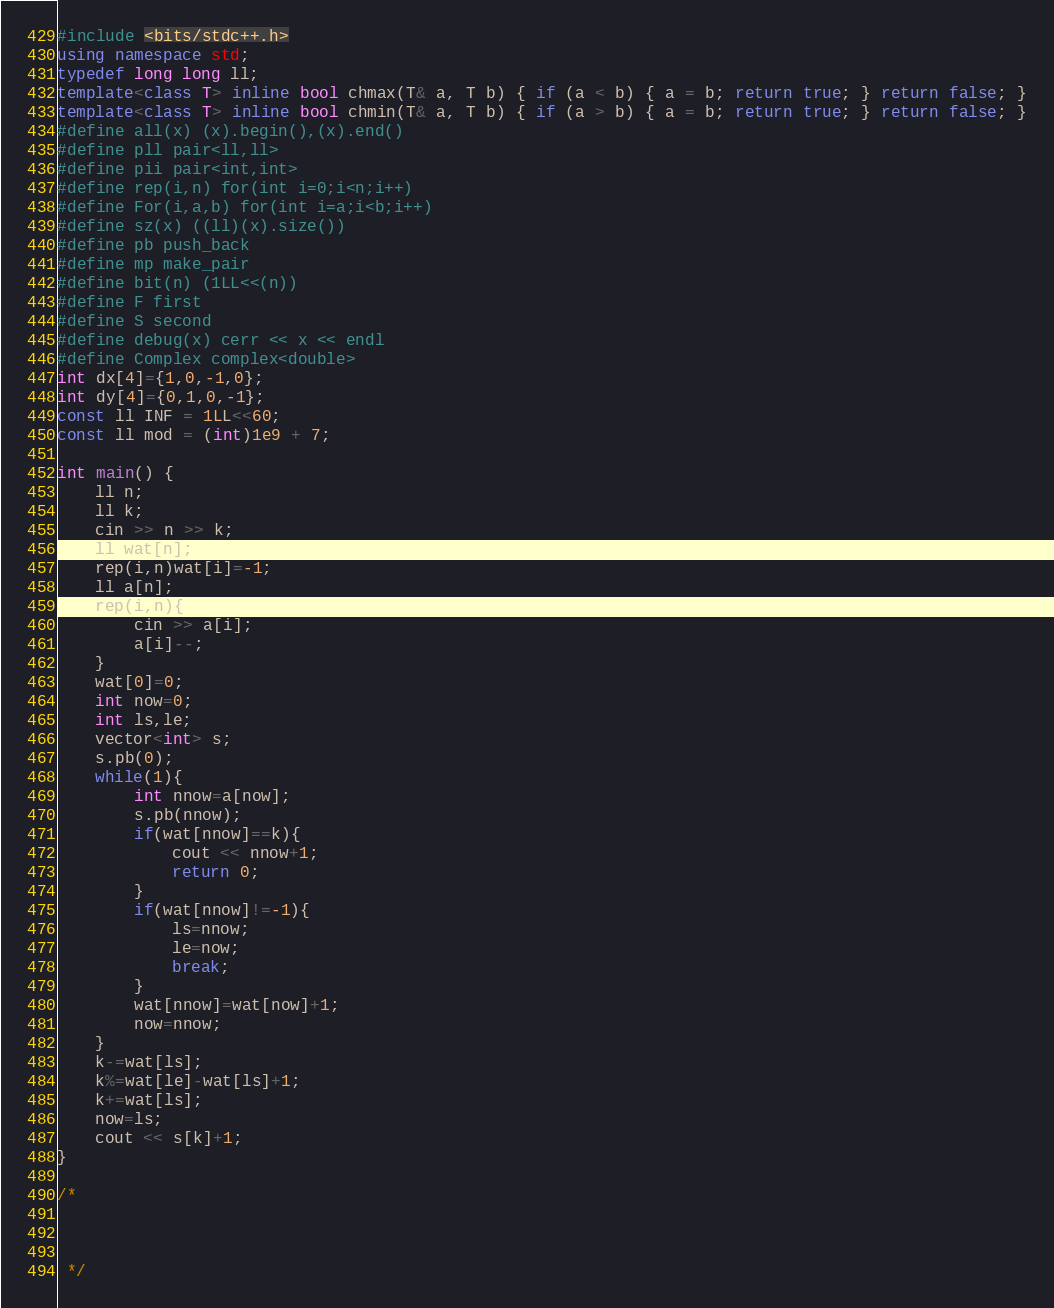<code> <loc_0><loc_0><loc_500><loc_500><_C++_>#include <bits/stdc++.h>
using namespace std;
typedef long long ll;
template<class T> inline bool chmax(T& a, T b) { if (a < b) { a = b; return true; } return false; }
template<class T> inline bool chmin(T& a, T b) { if (a > b) { a = b; return true; } return false; }
#define all(x) (x).begin(),(x).end()
#define pll pair<ll,ll>
#define pii pair<int,int>
#define rep(i,n) for(int i=0;i<n;i++)
#define For(i,a,b) for(int i=a;i<b;i++)
#define sz(x) ((ll)(x).size())
#define pb push_back
#define mp make_pair
#define bit(n) (1LL<<(n))
#define F first
#define S second
#define debug(x) cerr << x << endl
#define Complex complex<double>
int dx[4]={1,0,-1,0};
int dy[4]={0,1,0,-1};
const ll INF = 1LL<<60;
const ll mod = (int)1e9 + 7;

int main() {
    ll n;
    ll k;
    cin >> n >> k;
    ll wat[n];
    rep(i,n)wat[i]=-1;
    ll a[n];
    rep(i,n){
        cin >> a[i];
        a[i]--;
    }
    wat[0]=0;
    int now=0;
    int ls,le;
  	vector<int> s;
  	s.pb(0);
    while(1){
        int nnow=a[now];
      	s.pb(nnow);
        if(wat[nnow]==k){
            cout << nnow+1;
            return 0;
        }
        if(wat[nnow]!=-1){
            ls=nnow;
            le=now;
            break;
        }
        wat[nnow]=wat[now]+1;
        now=nnow;
    }
    k-=wat[ls];
    k%=wat[le]-wat[ls]+1;
    k+=wat[ls];
    now=ls;
	cout << s[k]+1;
}

/*



 */


</code> 